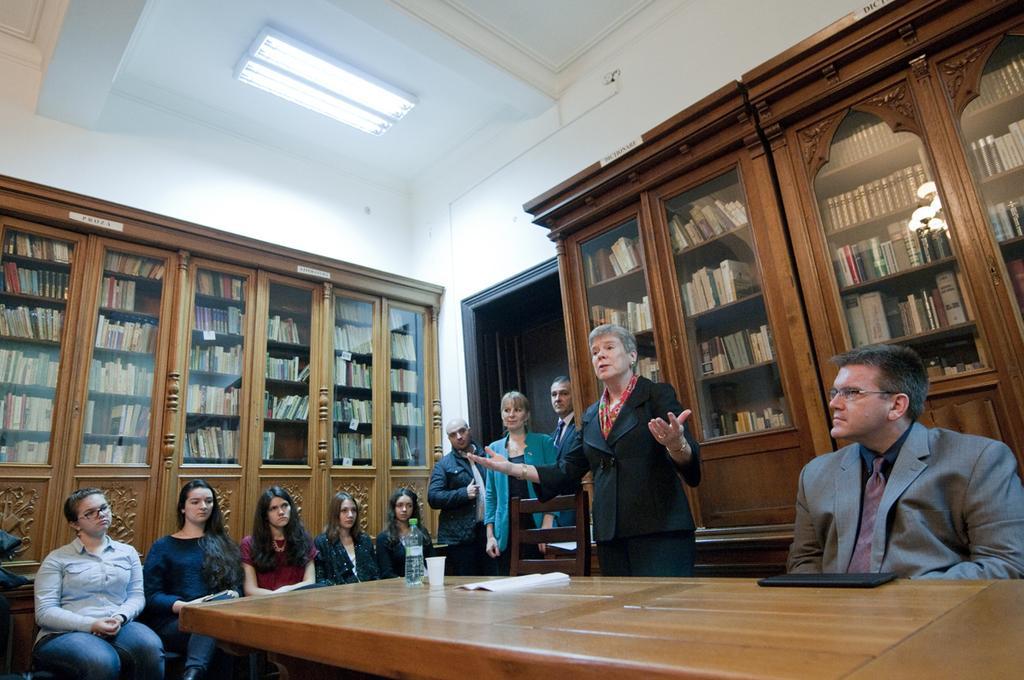Describe this image in one or two sentences. In front, we can see table on which laptop, papers, glass and water bottle is placed. We can see many people sitting on the chairs and four of them are standing. The woman in black blazer is is talking to the people sitting on the chairs. To the right of this picture, we can see man in grey blazer watching watching her. He is wearing spectacles. Five on the left of the table are sitting on the chair and watching and listening to the listening to the woman. Behind them, we see a rack or a cupboard with bunch of books. Beside them we see two men and a woman standing. Beside, behind them we find a door and a wall which is white in color. 